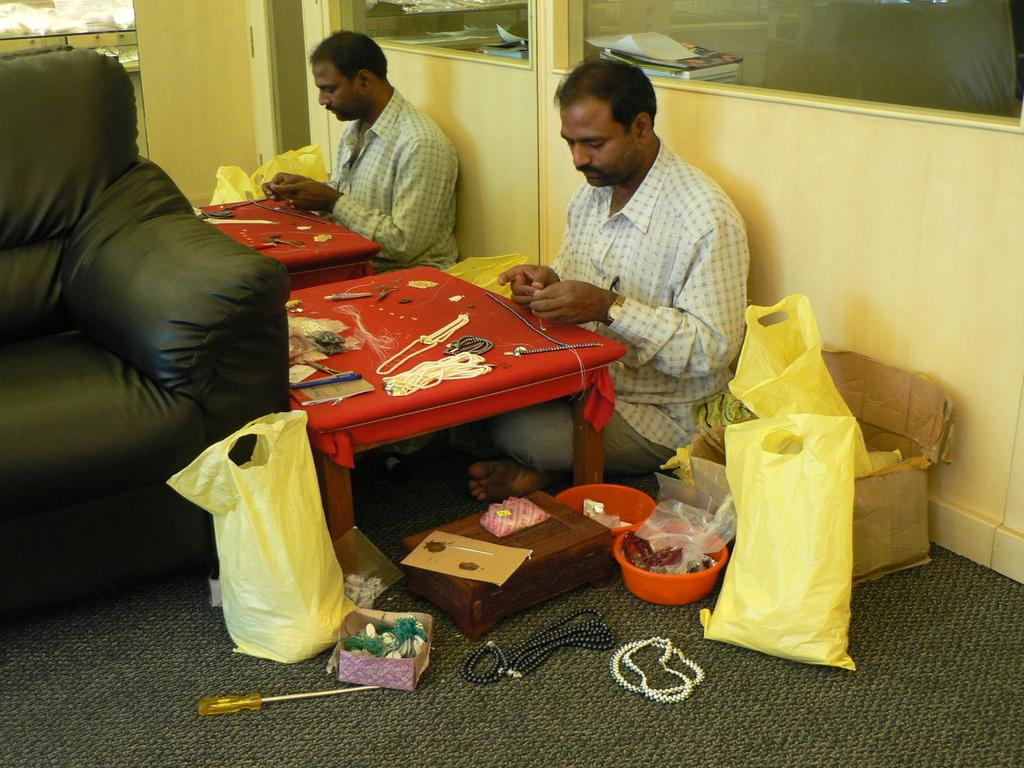What is the man in the image doing? The man is sitting on the floor in the image. What items can be seen near the man? There are carry bags in the image. What furniture is present in the image? There is a table and a sofa in the image. What object is used for reflection in the image? There is a mirror in the image. What can be used for work or repair in the image? There are tools visible in the image. What type of pickle is being served on the table in the image? There is no pickle present in the image; the focus is on the man, carry bags, table, sofa, mirror, and tools. 